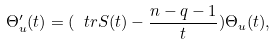Convert formula to latex. <formula><loc_0><loc_0><loc_500><loc_500>\Theta _ { u } ^ { \prime } ( t ) = ( \ t r S ( t ) - \frac { n - q - 1 } { t } ) \Theta _ { u } ( t ) ,</formula> 